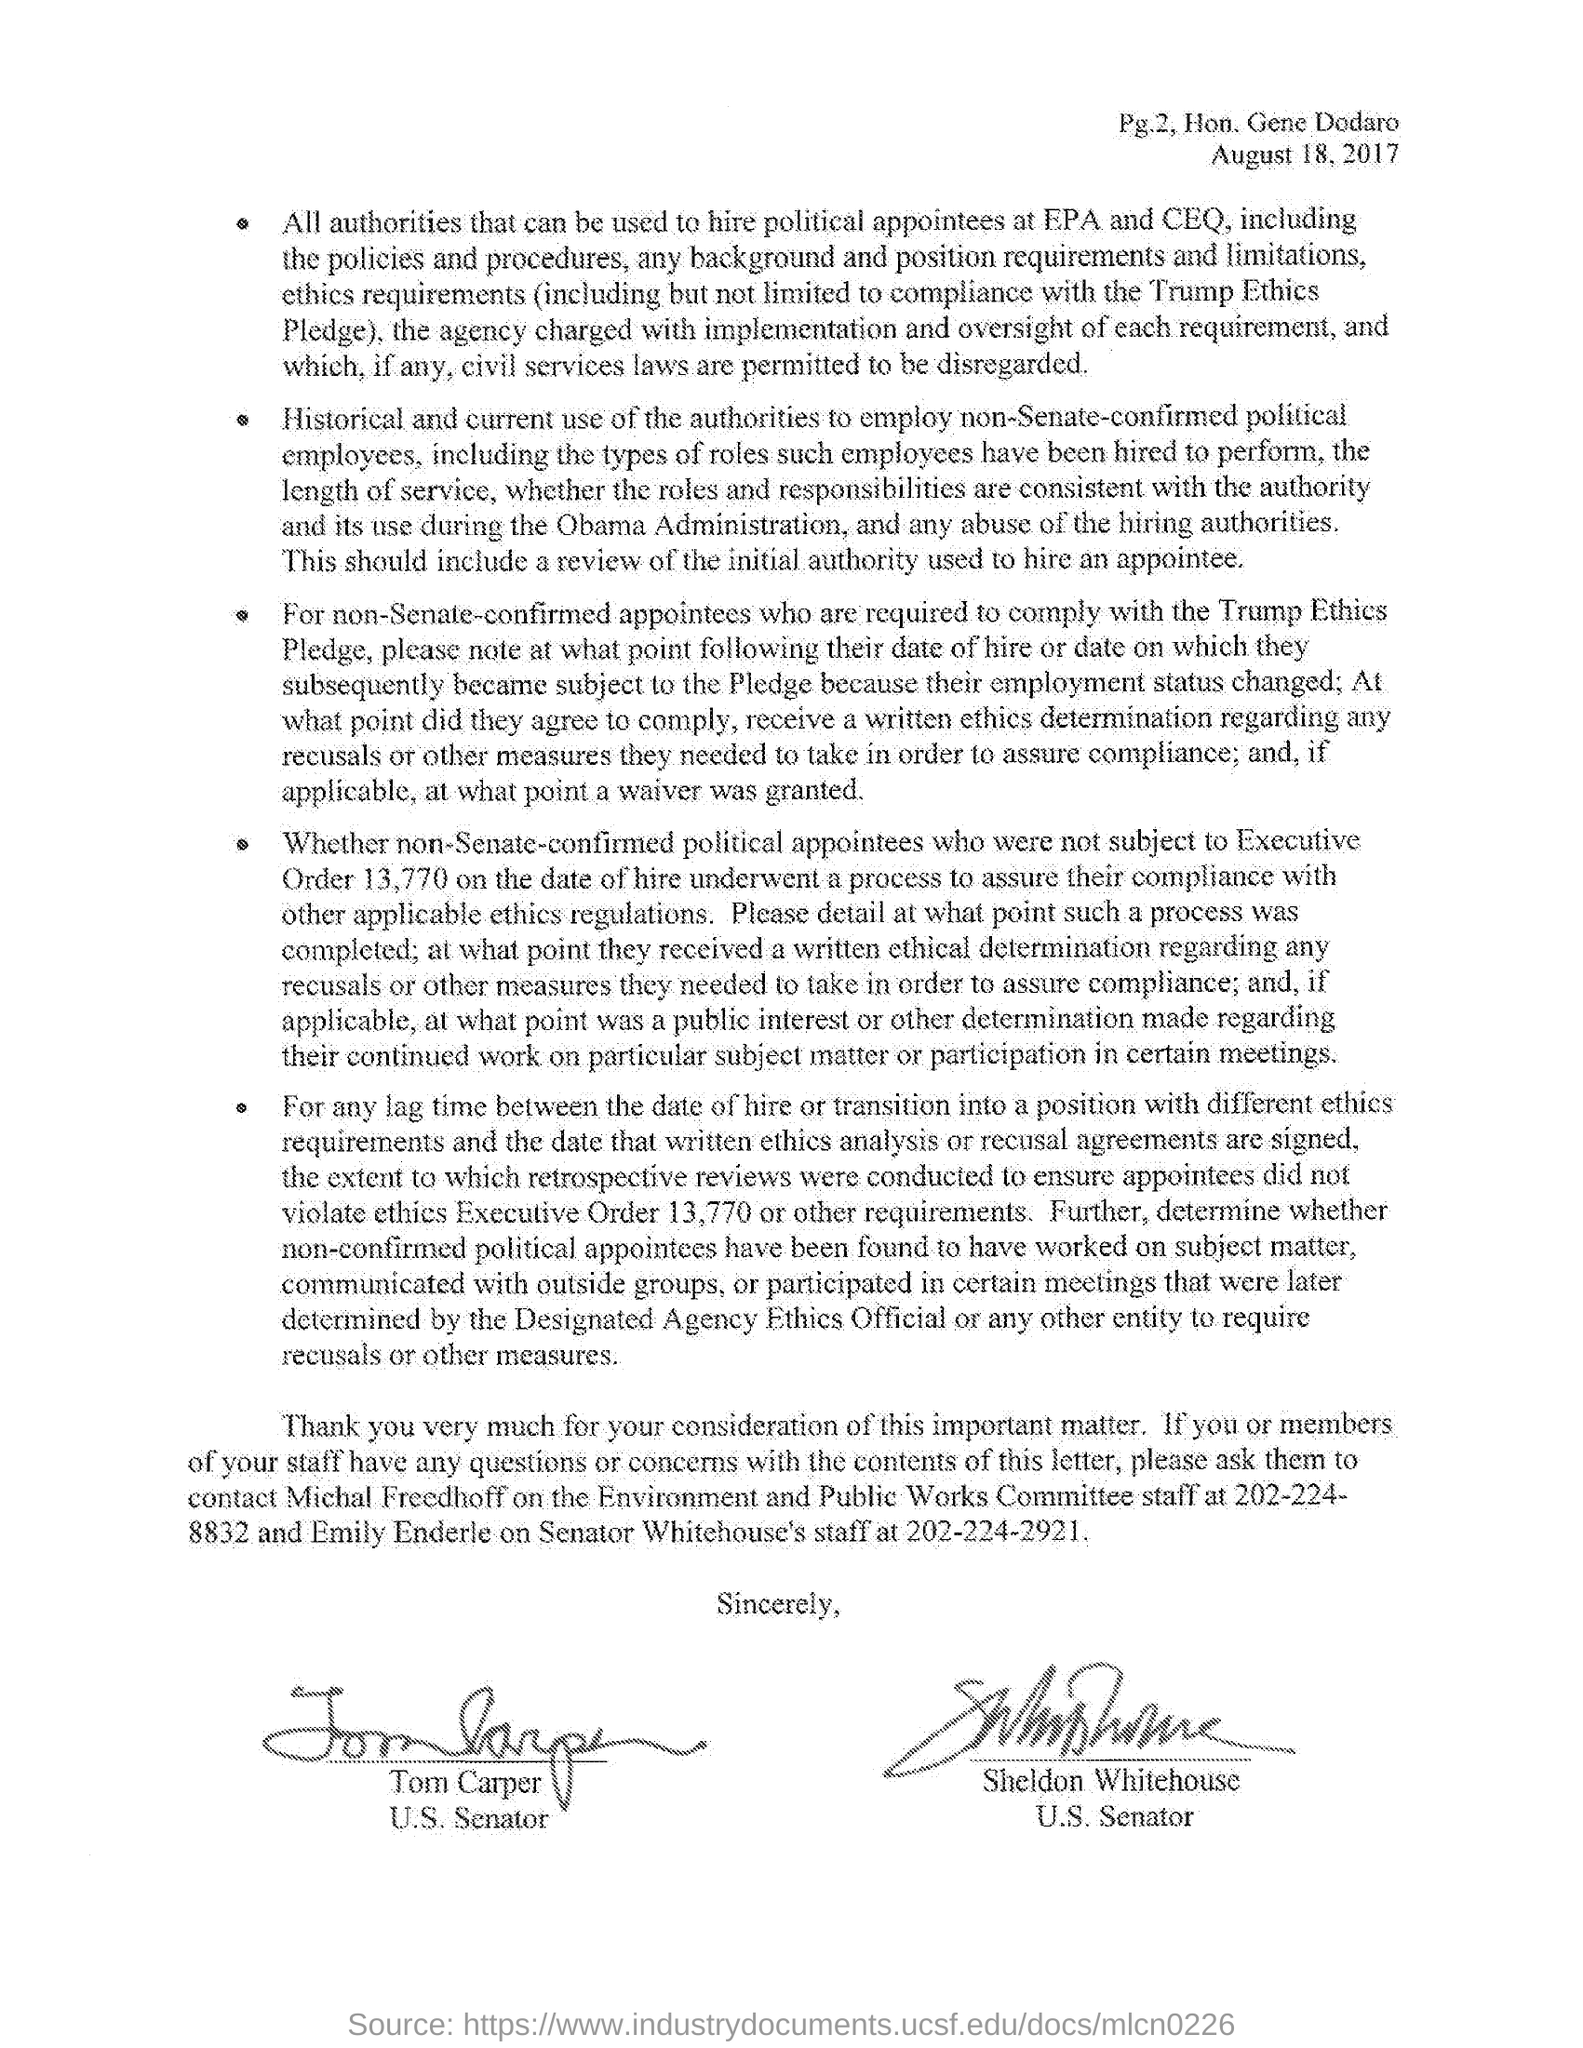Highlight a few significant elements in this photo. The staff member's name is Michal Freedhoff, and he works for the Environment and Public Works Committee. Emily Enderle is a staff member of Senator Whitehouse. Tom Carper is a United States Senator. The document's date of August 18, 2017, has been provided. The contact number of the staff of the Environment and Public Works Committe is 202-224-8832. 